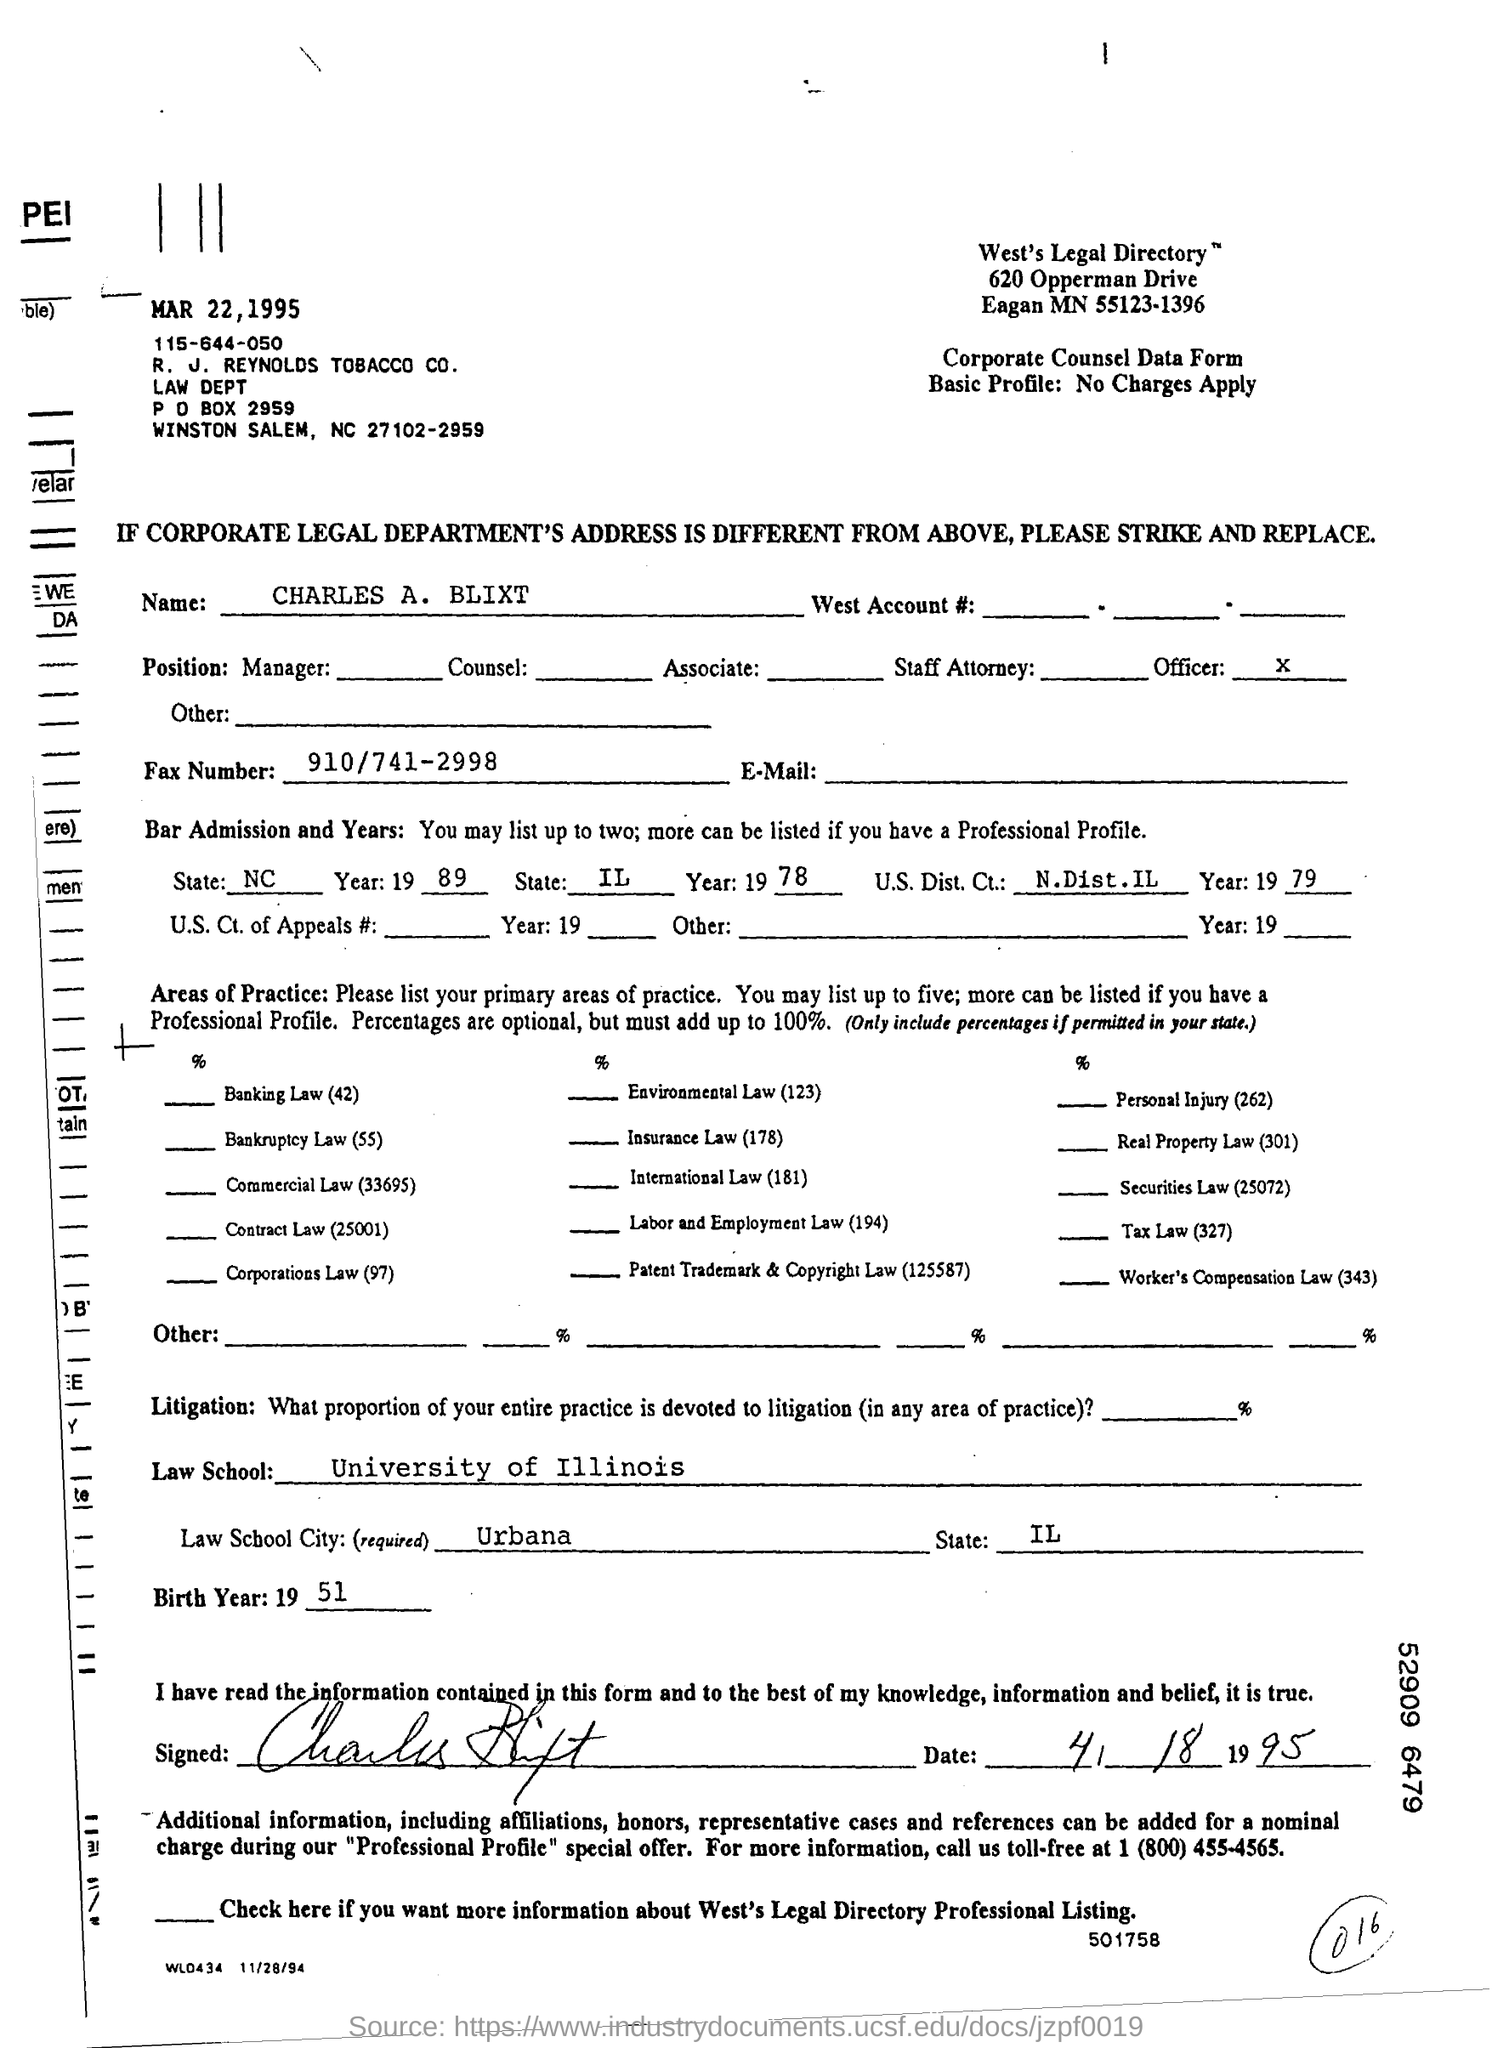Point out several critical features in this image. The fax number is 910/741-2998. The P O BOX Number is 2959. The information provided is that the birth year field contains the value "1951". The date mentioned at the top of the document is March 22, 1995. The city name of the law school is Urbana. 